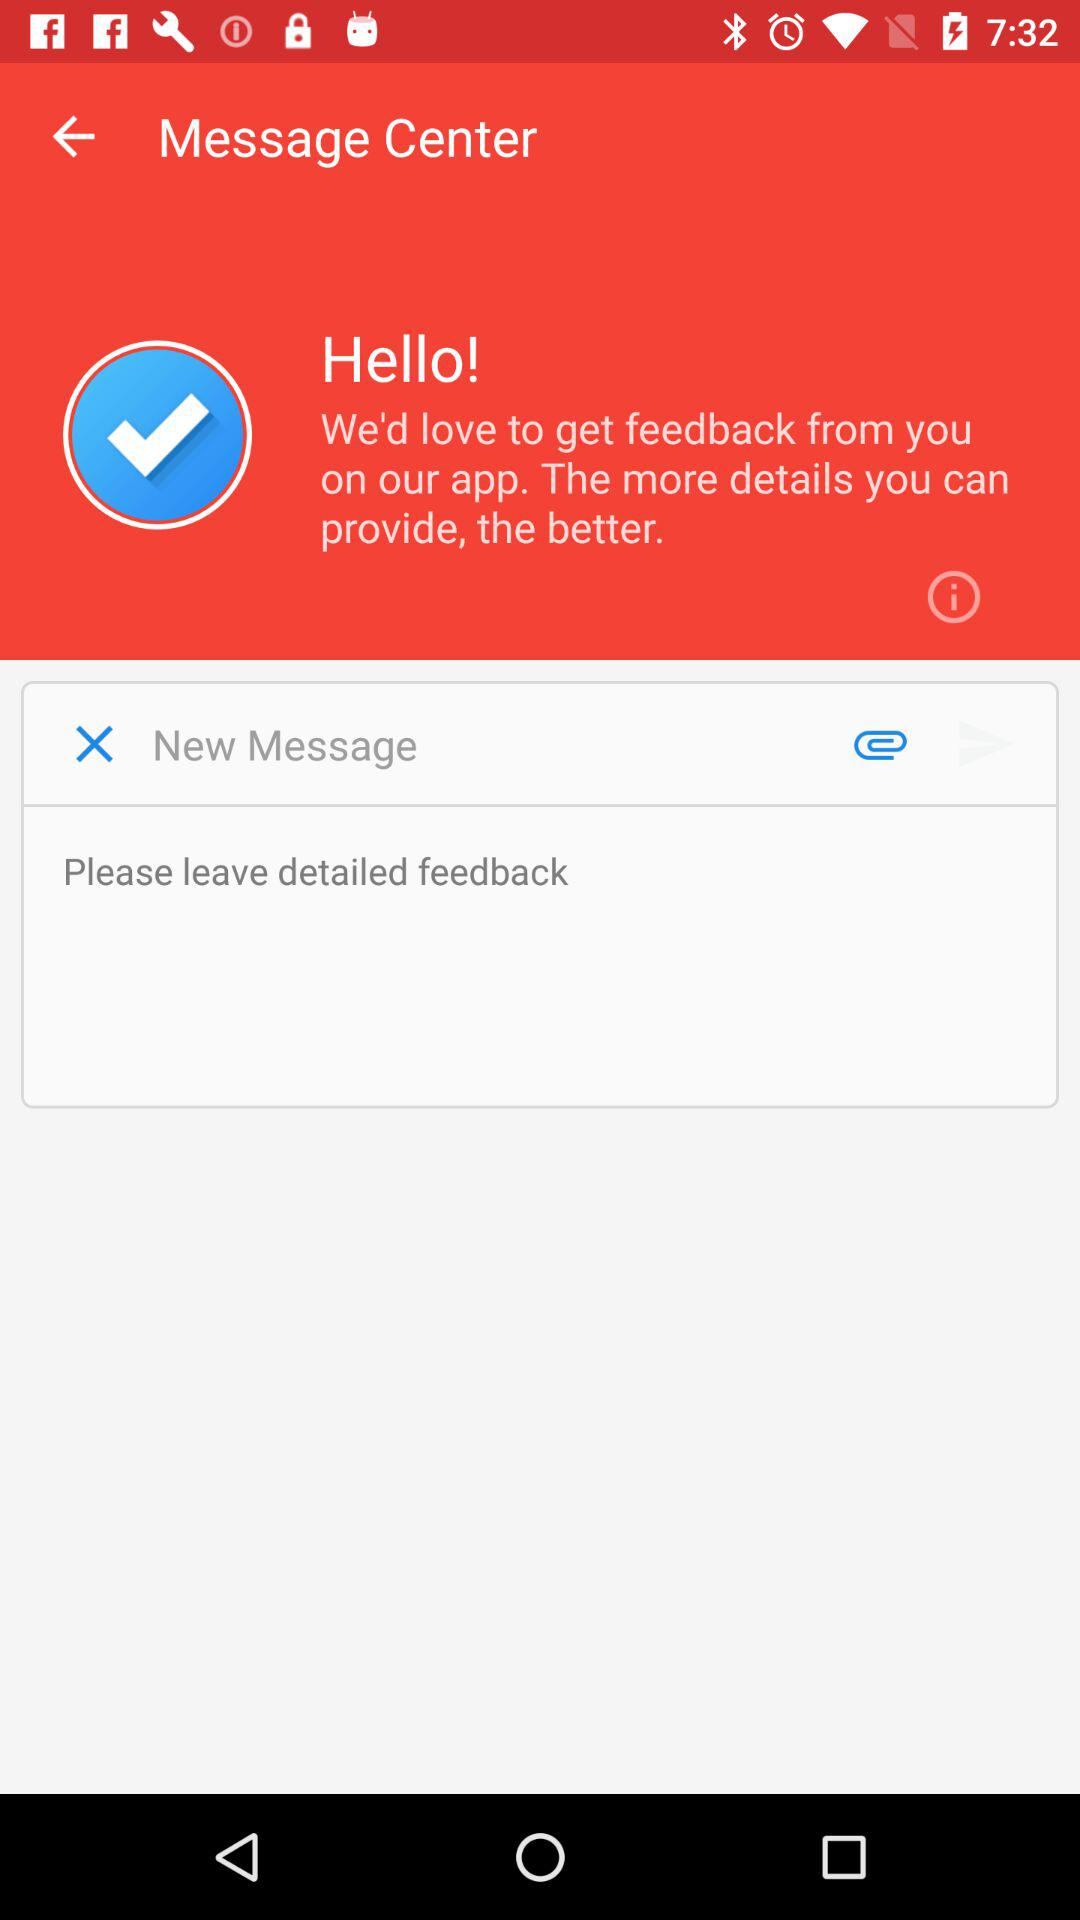How many more text inputs are there in the bottom half of the screen than the top half?
Answer the question using a single word or phrase. 1 